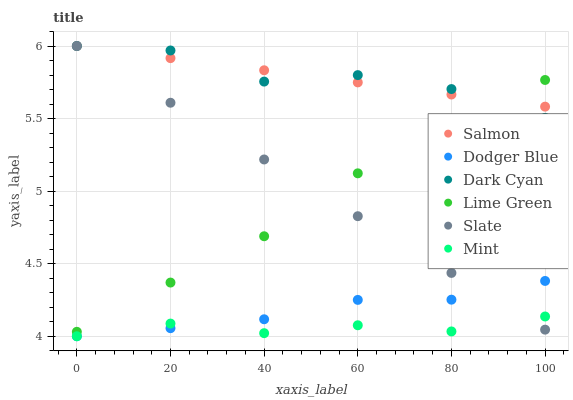Does Mint have the minimum area under the curve?
Answer yes or no. Yes. Does Dark Cyan have the maximum area under the curve?
Answer yes or no. Yes. Does Slate have the minimum area under the curve?
Answer yes or no. No. Does Slate have the maximum area under the curve?
Answer yes or no. No. Is Salmon the smoothest?
Answer yes or no. Yes. Is Dark Cyan the roughest?
Answer yes or no. Yes. Is Slate the smoothest?
Answer yes or no. No. Is Slate the roughest?
Answer yes or no. No. Does Dodger Blue have the lowest value?
Answer yes or no. Yes. Does Slate have the lowest value?
Answer yes or no. No. Does Dark Cyan have the highest value?
Answer yes or no. Yes. Does Dodger Blue have the highest value?
Answer yes or no. No. Is Dodger Blue less than Dark Cyan?
Answer yes or no. Yes. Is Dark Cyan greater than Dodger Blue?
Answer yes or no. Yes. Does Mint intersect Dodger Blue?
Answer yes or no. Yes. Is Mint less than Dodger Blue?
Answer yes or no. No. Is Mint greater than Dodger Blue?
Answer yes or no. No. Does Dodger Blue intersect Dark Cyan?
Answer yes or no. No. 